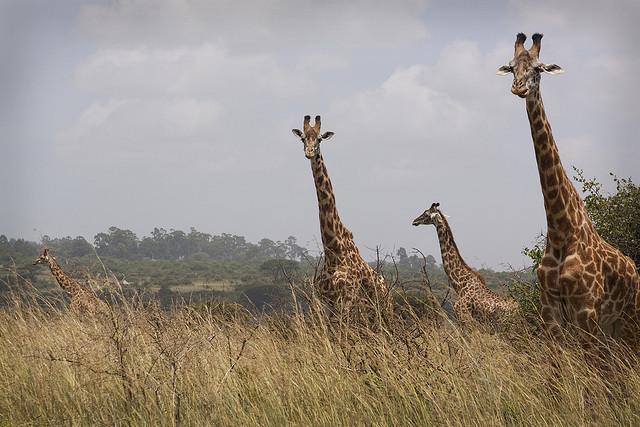How many giraffes are there?
Give a very brief answer. 4. How many zebras are there?
Give a very brief answer. 0. How many giraffes can you see?
Give a very brief answer. 3. 